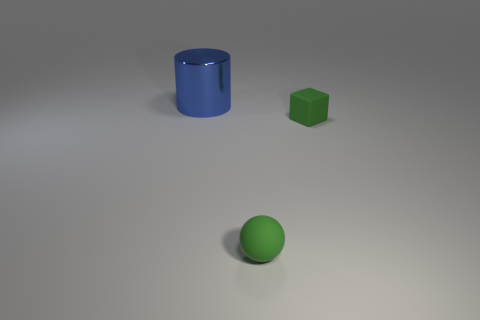Is the material of the object behind the rubber block the same as the green thing right of the green rubber ball?
Ensure brevity in your answer.  No. Is the number of green matte spheres greater than the number of large green objects?
Your response must be concise. Yes. Are there any other things of the same color as the rubber ball?
Your answer should be compact. Yes. Are the cube and the blue cylinder made of the same material?
Your response must be concise. No. Is the number of small matte spheres less than the number of matte objects?
Provide a succinct answer. Yes. The small block has what color?
Keep it short and to the point. Green. What number of other things are made of the same material as the ball?
Your answer should be very brief. 1. What number of blue objects are either large metal cubes or big shiny things?
Ensure brevity in your answer.  1. Does the thing in front of the small green matte block have the same shape as the thing that is on the right side of the sphere?
Keep it short and to the point. No. Do the large cylinder and the thing that is right of the ball have the same color?
Offer a terse response. No. 